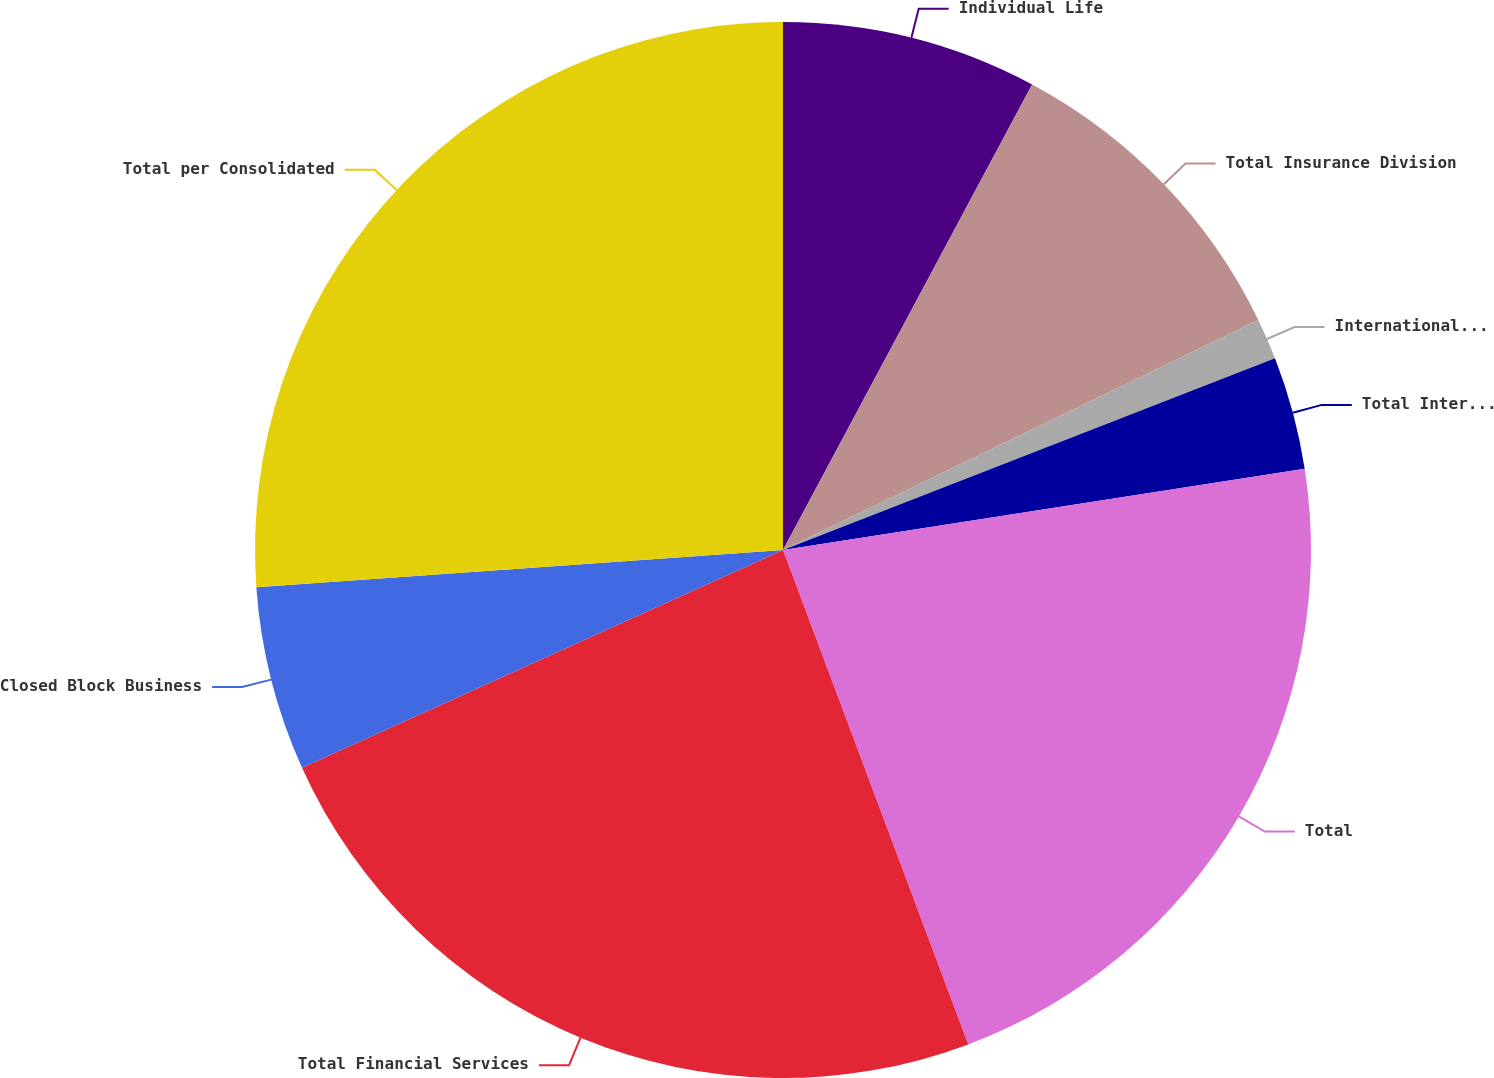Convert chart to OTSL. <chart><loc_0><loc_0><loc_500><loc_500><pie_chart><fcel>Individual Life<fcel>Total Insurance Division<fcel>International Insurance<fcel>Total International Insurance<fcel>Total<fcel>Total Financial Services<fcel>Closed Block Business<fcel>Total per Consolidated<nl><fcel>7.82%<fcel>10.01%<fcel>1.26%<fcel>3.45%<fcel>21.76%<fcel>23.94%<fcel>5.64%<fcel>26.13%<nl></chart> 